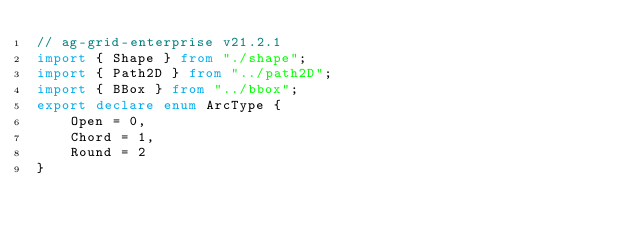Convert code to text. <code><loc_0><loc_0><loc_500><loc_500><_TypeScript_>// ag-grid-enterprise v21.2.1
import { Shape } from "./shape";
import { Path2D } from "../path2D";
import { BBox } from "../bbox";
export declare enum ArcType {
    Open = 0,
    Chord = 1,
    Round = 2
}</code> 